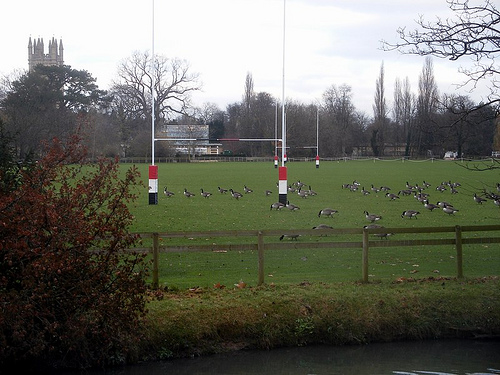<image>
Is the bird in the sky? No. The bird is not contained within the sky. These objects have a different spatial relationship. Is the goal post behind the tree? No. The goal post is not behind the tree. From this viewpoint, the goal post appears to be positioned elsewhere in the scene. 